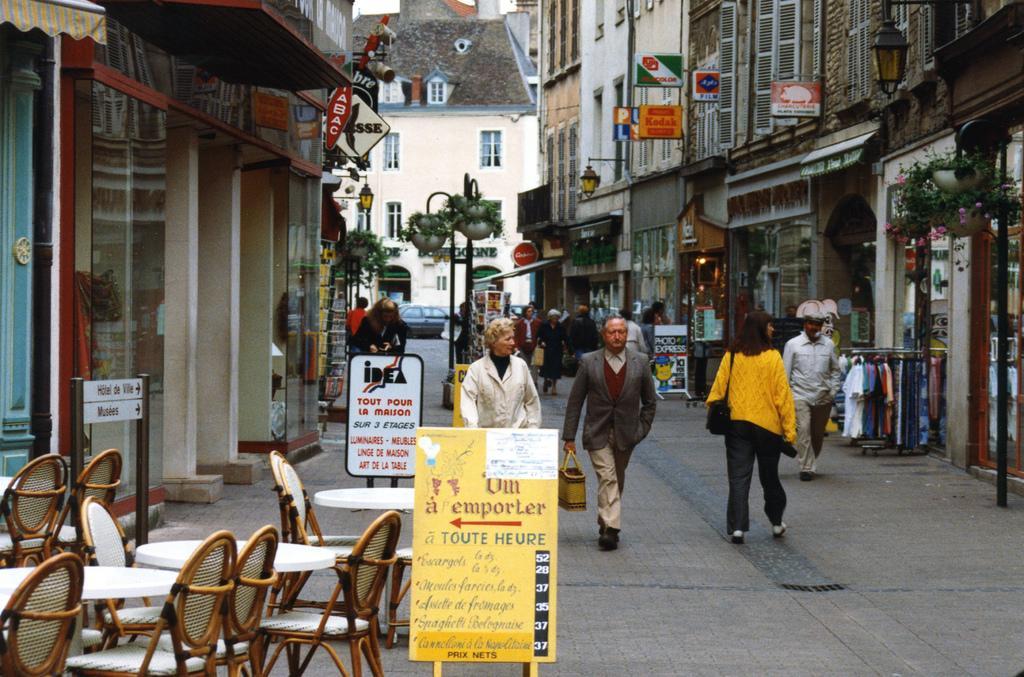Please provide a concise description of this image. In the image we can see there are people standing on the footpath and there are tables and chairs on the footpath. There are banners kept on the ground and there are buildings. There are hoardings on the building. 